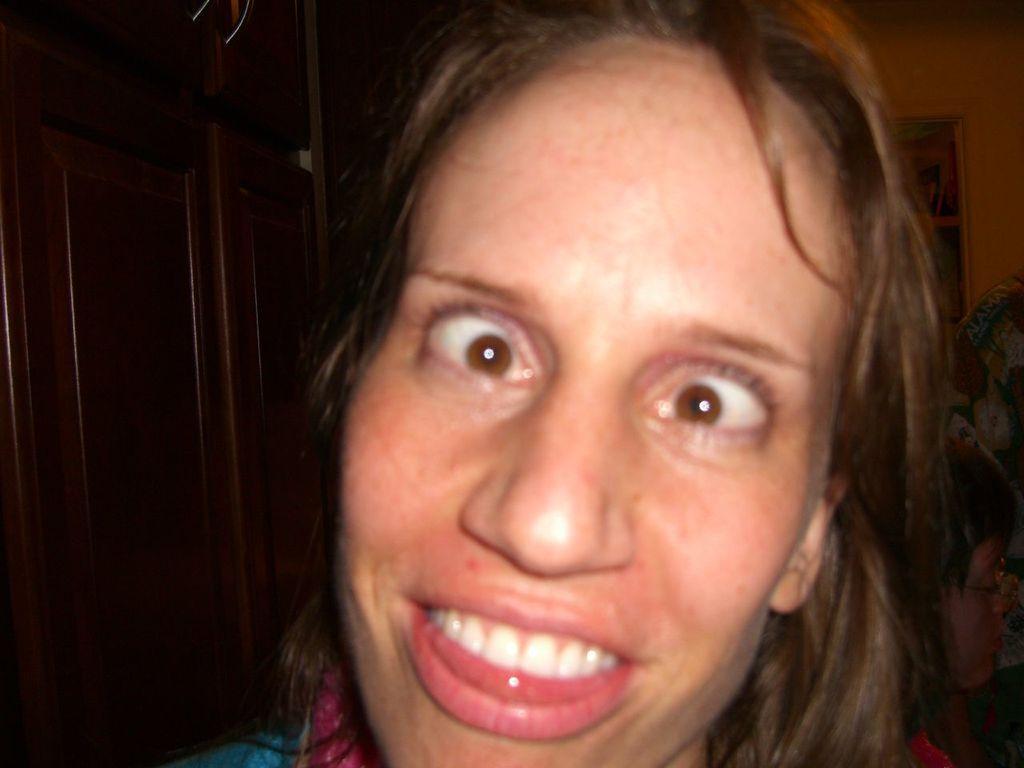Could you give a brief overview of what you see in this image? In this image in the front there is a woman having some expression on her face. In the background there is a shelf and there is a cupboard and there are objects on the right side. 